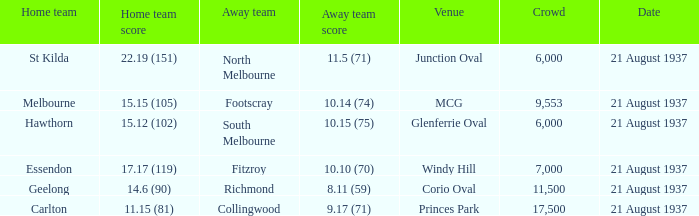Where did Richmond play? Corio Oval. 